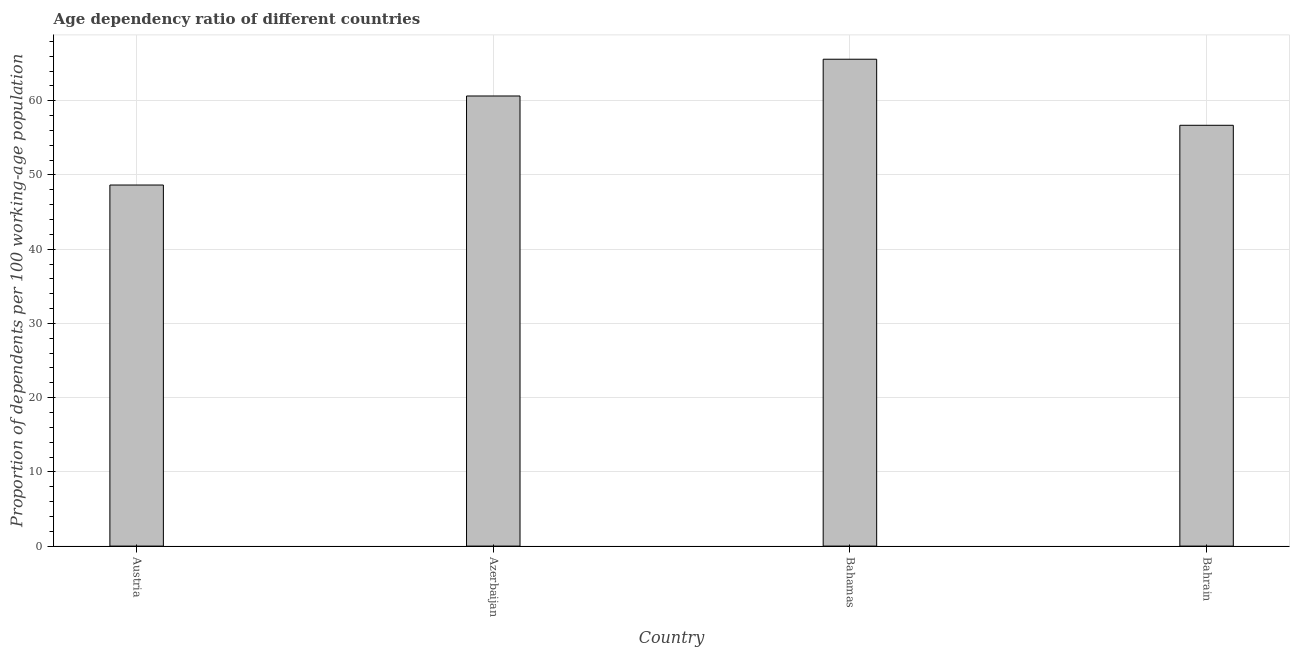Does the graph contain grids?
Give a very brief answer. Yes. What is the title of the graph?
Offer a terse response. Age dependency ratio of different countries. What is the label or title of the X-axis?
Your response must be concise. Country. What is the label or title of the Y-axis?
Your answer should be compact. Proportion of dependents per 100 working-age population. What is the age dependency ratio in Bahrain?
Keep it short and to the point. 56.7. Across all countries, what is the maximum age dependency ratio?
Provide a short and direct response. 65.6. Across all countries, what is the minimum age dependency ratio?
Keep it short and to the point. 48.65. In which country was the age dependency ratio maximum?
Ensure brevity in your answer.  Bahamas. What is the sum of the age dependency ratio?
Your response must be concise. 231.59. What is the difference between the age dependency ratio in Austria and Bahamas?
Offer a very short reply. -16.95. What is the average age dependency ratio per country?
Your response must be concise. 57.9. What is the median age dependency ratio?
Give a very brief answer. 58.67. In how many countries, is the age dependency ratio greater than 2 ?
Provide a short and direct response. 4. What is the ratio of the age dependency ratio in Azerbaijan to that in Bahrain?
Keep it short and to the point. 1.07. Is the age dependency ratio in Azerbaijan less than that in Bahrain?
Provide a short and direct response. No. What is the difference between the highest and the second highest age dependency ratio?
Your answer should be very brief. 4.95. Is the sum of the age dependency ratio in Austria and Bahrain greater than the maximum age dependency ratio across all countries?
Your response must be concise. Yes. What is the difference between the highest and the lowest age dependency ratio?
Offer a very short reply. 16.95. How many bars are there?
Make the answer very short. 4. Are all the bars in the graph horizontal?
Give a very brief answer. No. What is the difference between two consecutive major ticks on the Y-axis?
Give a very brief answer. 10. Are the values on the major ticks of Y-axis written in scientific E-notation?
Ensure brevity in your answer.  No. What is the Proportion of dependents per 100 working-age population in Austria?
Make the answer very short. 48.65. What is the Proportion of dependents per 100 working-age population in Azerbaijan?
Make the answer very short. 60.65. What is the Proportion of dependents per 100 working-age population in Bahamas?
Offer a terse response. 65.6. What is the Proportion of dependents per 100 working-age population in Bahrain?
Your answer should be compact. 56.7. What is the difference between the Proportion of dependents per 100 working-age population in Austria and Azerbaijan?
Make the answer very short. -12. What is the difference between the Proportion of dependents per 100 working-age population in Austria and Bahamas?
Make the answer very short. -16.95. What is the difference between the Proportion of dependents per 100 working-age population in Austria and Bahrain?
Your answer should be compact. -8.05. What is the difference between the Proportion of dependents per 100 working-age population in Azerbaijan and Bahamas?
Give a very brief answer. -4.95. What is the difference between the Proportion of dependents per 100 working-age population in Azerbaijan and Bahrain?
Provide a short and direct response. 3.95. What is the difference between the Proportion of dependents per 100 working-age population in Bahamas and Bahrain?
Your response must be concise. 8.9. What is the ratio of the Proportion of dependents per 100 working-age population in Austria to that in Azerbaijan?
Give a very brief answer. 0.8. What is the ratio of the Proportion of dependents per 100 working-age population in Austria to that in Bahamas?
Ensure brevity in your answer.  0.74. What is the ratio of the Proportion of dependents per 100 working-age population in Austria to that in Bahrain?
Give a very brief answer. 0.86. What is the ratio of the Proportion of dependents per 100 working-age population in Azerbaijan to that in Bahamas?
Your answer should be very brief. 0.92. What is the ratio of the Proportion of dependents per 100 working-age population in Azerbaijan to that in Bahrain?
Make the answer very short. 1.07. What is the ratio of the Proportion of dependents per 100 working-age population in Bahamas to that in Bahrain?
Provide a succinct answer. 1.16. 